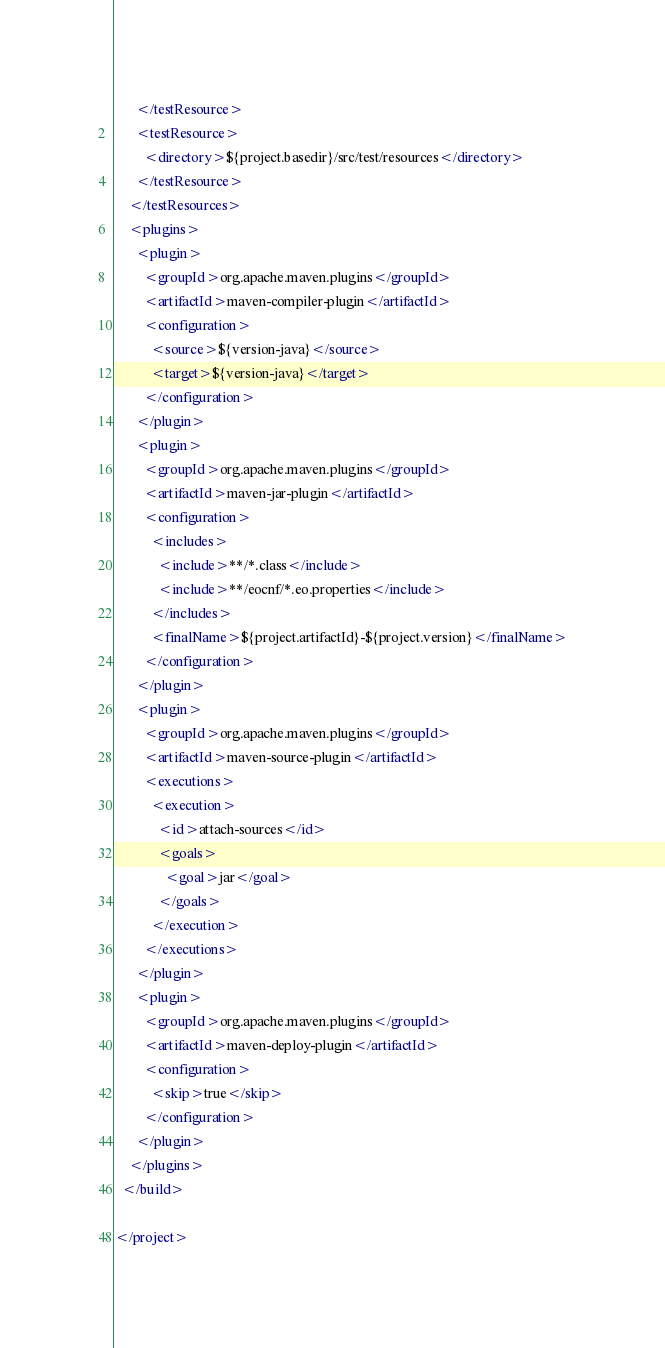Convert code to text. <code><loc_0><loc_0><loc_500><loc_500><_XML_>      </testResource>
      <testResource>
        <directory>${project.basedir}/src/test/resources</directory>
      </testResource>
    </testResources>
    <plugins>
      <plugin>
        <groupId>org.apache.maven.plugins</groupId>
        <artifactId>maven-compiler-plugin</artifactId>
        <configuration>
          <source>${version-java}</source>
          <target>${version-java}</target>
        </configuration>
      </plugin>
      <plugin>
        <groupId>org.apache.maven.plugins</groupId>
        <artifactId>maven-jar-plugin</artifactId>
        <configuration>
          <includes>
            <include>**/*.class</include>
            <include>**/eocnf/*.eo.properties</include>
          </includes>
          <finalName>${project.artifactId}-${project.version}</finalName>
        </configuration>
      </plugin>
      <plugin>
        <groupId>org.apache.maven.plugins</groupId>
        <artifactId>maven-source-plugin</artifactId>
        <executions>
          <execution>
            <id>attach-sources</id>
            <goals>
              <goal>jar</goal>
            </goals>
          </execution>
        </executions>
      </plugin>
      <plugin>
        <groupId>org.apache.maven.plugins</groupId>
        <artifactId>maven-deploy-plugin</artifactId>
        <configuration>
          <skip>true</skip>
        </configuration>
      </plugin>
    </plugins>
  </build>

</project>
</code> 